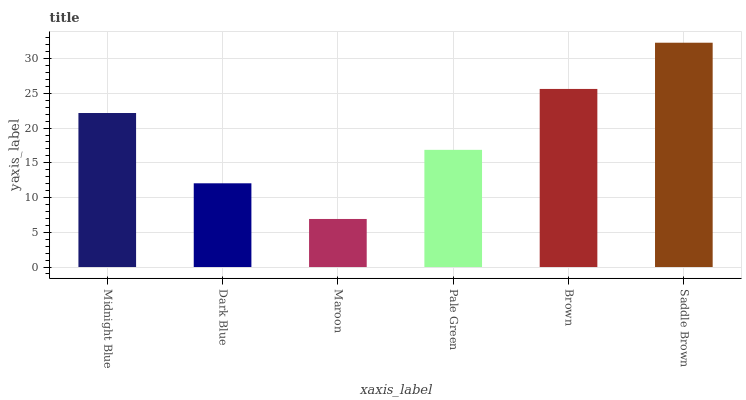Is Maroon the minimum?
Answer yes or no. Yes. Is Saddle Brown the maximum?
Answer yes or no. Yes. Is Dark Blue the minimum?
Answer yes or no. No. Is Dark Blue the maximum?
Answer yes or no. No. Is Midnight Blue greater than Dark Blue?
Answer yes or no. Yes. Is Dark Blue less than Midnight Blue?
Answer yes or no. Yes. Is Dark Blue greater than Midnight Blue?
Answer yes or no. No. Is Midnight Blue less than Dark Blue?
Answer yes or no. No. Is Midnight Blue the high median?
Answer yes or no. Yes. Is Pale Green the low median?
Answer yes or no. Yes. Is Saddle Brown the high median?
Answer yes or no. No. Is Saddle Brown the low median?
Answer yes or no. No. 